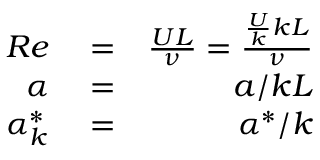Convert formula to latex. <formula><loc_0><loc_0><loc_500><loc_500>\begin{array} { r l r } { R e } & = } & { \frac { U L } { \nu } = \frac { \frac { U } { k } k L } { \nu } } \\ { \alpha } & = } & { a / k L } \\ { \alpha _ { k } ^ { * } } & = } & { \alpha ^ { * } / k } \end{array}</formula> 